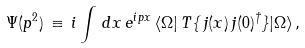<formula> <loc_0><loc_0><loc_500><loc_500>\Psi ( p ^ { 2 } ) \, \equiv \, i \int \, d x \, e ^ { i p x } \, \langle \Omega | \, T \{ \, j ( x ) \, j ( 0 ) ^ { \dagger } \} | \Omega \rangle \, ,</formula> 